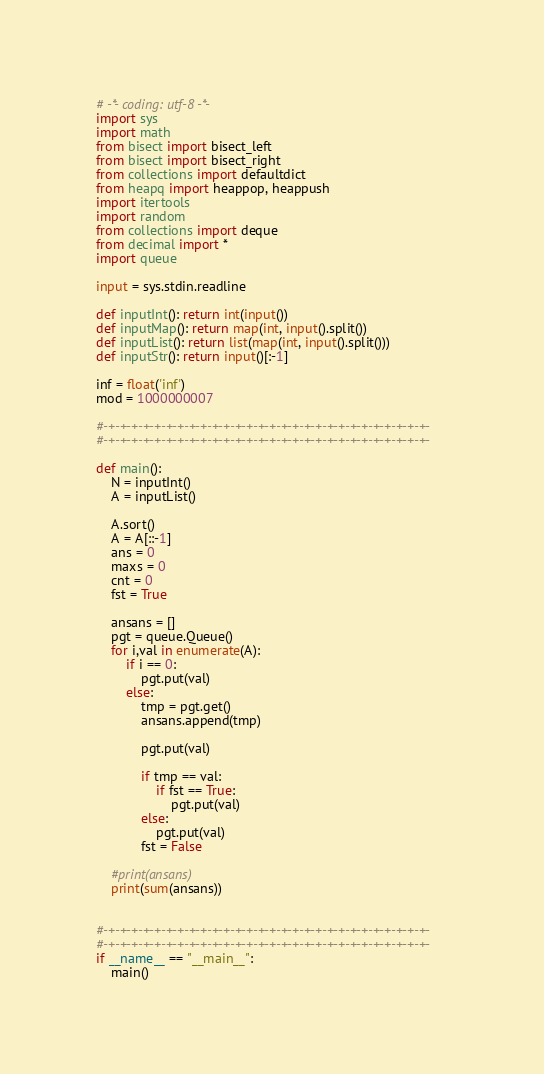Convert code to text. <code><loc_0><loc_0><loc_500><loc_500><_Python_># -*- coding: utf-8 -*-
import sys
import math
from bisect import bisect_left
from bisect import bisect_right
from collections import defaultdict
from heapq import heappop, heappush
import itertools
import random
from collections import deque
from decimal import *
import queue

input = sys.stdin.readline

def inputInt(): return int(input())
def inputMap(): return map(int, input().split())
def inputList(): return list(map(int, input().split()))
def inputStr(): return input()[:-1]

inf = float('inf')
mod = 1000000007

#-+-+-+-+-+-+-+-+-+-+-+-+-+-+-+-+-+-+-+-+-+-+-+-+-+-+-+-+-
#-+-+-+-+-+-+-+-+-+-+-+-+-+-+-+-+-+-+-+-+-+-+-+-+-+-+-+-+-

def main():
	N = inputInt()
	A = inputList()

	A.sort()
	A = A[::-1]
	ans = 0
	maxs = 0
	cnt = 0
	fst = True

	ansans = []
	pgt = queue.Queue()
	for i,val in enumerate(A):
		if i == 0:
			pgt.put(val)
		else:
			tmp = pgt.get()
			ansans.append(tmp)

			pgt.put(val)

			if tmp == val:
				if fst == True:
					pgt.put(val)
			else:
				pgt.put(val)
			fst = False

	#print(ansans)
	print(sum(ansans))


#-+-+-+-+-+-+-+-+-+-+-+-+-+-+-+-+-+-+-+-+-+-+-+-+-+-+-+-+-
#-+-+-+-+-+-+-+-+-+-+-+-+-+-+-+-+-+-+-+-+-+-+-+-+-+-+-+-+-
if __name__ == "__main__":
	main()
</code> 